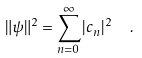<formula> <loc_0><loc_0><loc_500><loc_500>\| \psi \| ^ { 2 } = \sum _ { n = 0 } ^ { \infty } | c _ { n } | ^ { 2 } \ \ .</formula> 